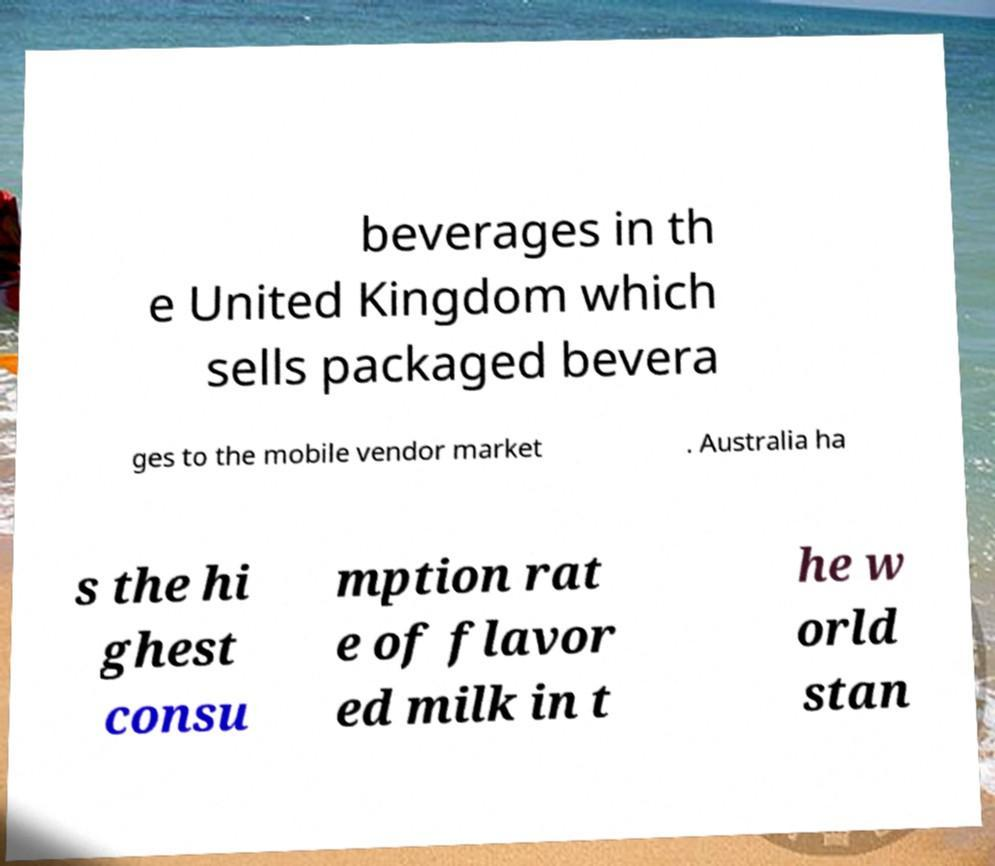Can you accurately transcribe the text from the provided image for me? beverages in th e United Kingdom which sells packaged bevera ges to the mobile vendor market . Australia ha s the hi ghest consu mption rat e of flavor ed milk in t he w orld stan 